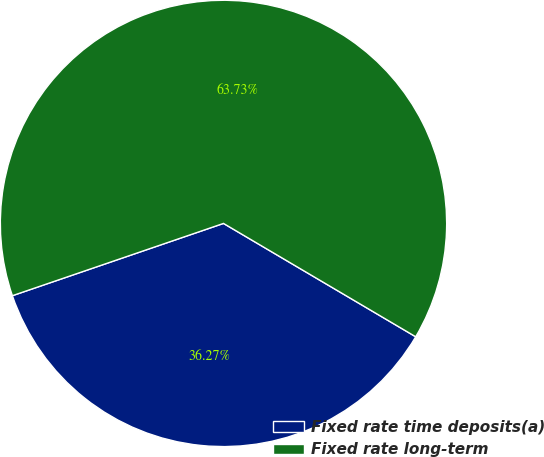Convert chart to OTSL. <chart><loc_0><loc_0><loc_500><loc_500><pie_chart><fcel>Fixed rate time deposits(a)<fcel>Fixed rate long-term<nl><fcel>36.27%<fcel>63.73%<nl></chart> 